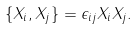Convert formula to latex. <formula><loc_0><loc_0><loc_500><loc_500>\{ X _ { i } , X _ { j } \} = \epsilon _ { i j } X _ { i } X _ { j } .</formula> 